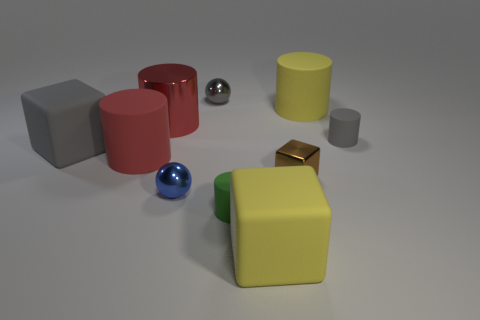Could you describe the lighting and shadows in the scene? The lighting appears to be coming from the upper left side, casting soft shadows to the right of the objects. This diffused lighting creates a calm atmosphere and accentuates the shapes and colors of the objects without producing harsh shadows. 